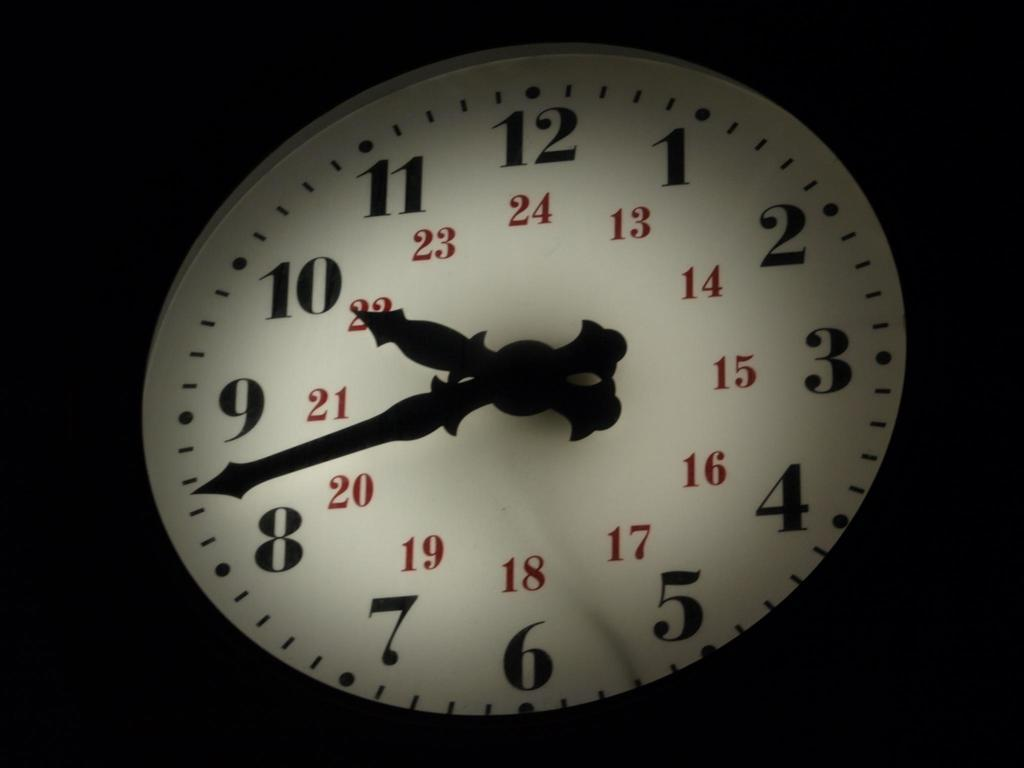What object can be seen in the image? There is a clock in the image. Can you describe the clock in more detail? Unfortunately, the provided facts do not offer any additional details about the clock. What might the clock be used for? The clock is likely used for telling time. What type of copper alloy is used to construct the spacecraft in the image? There is no spacecraft or mention of copper in the image; it only features a clock. 